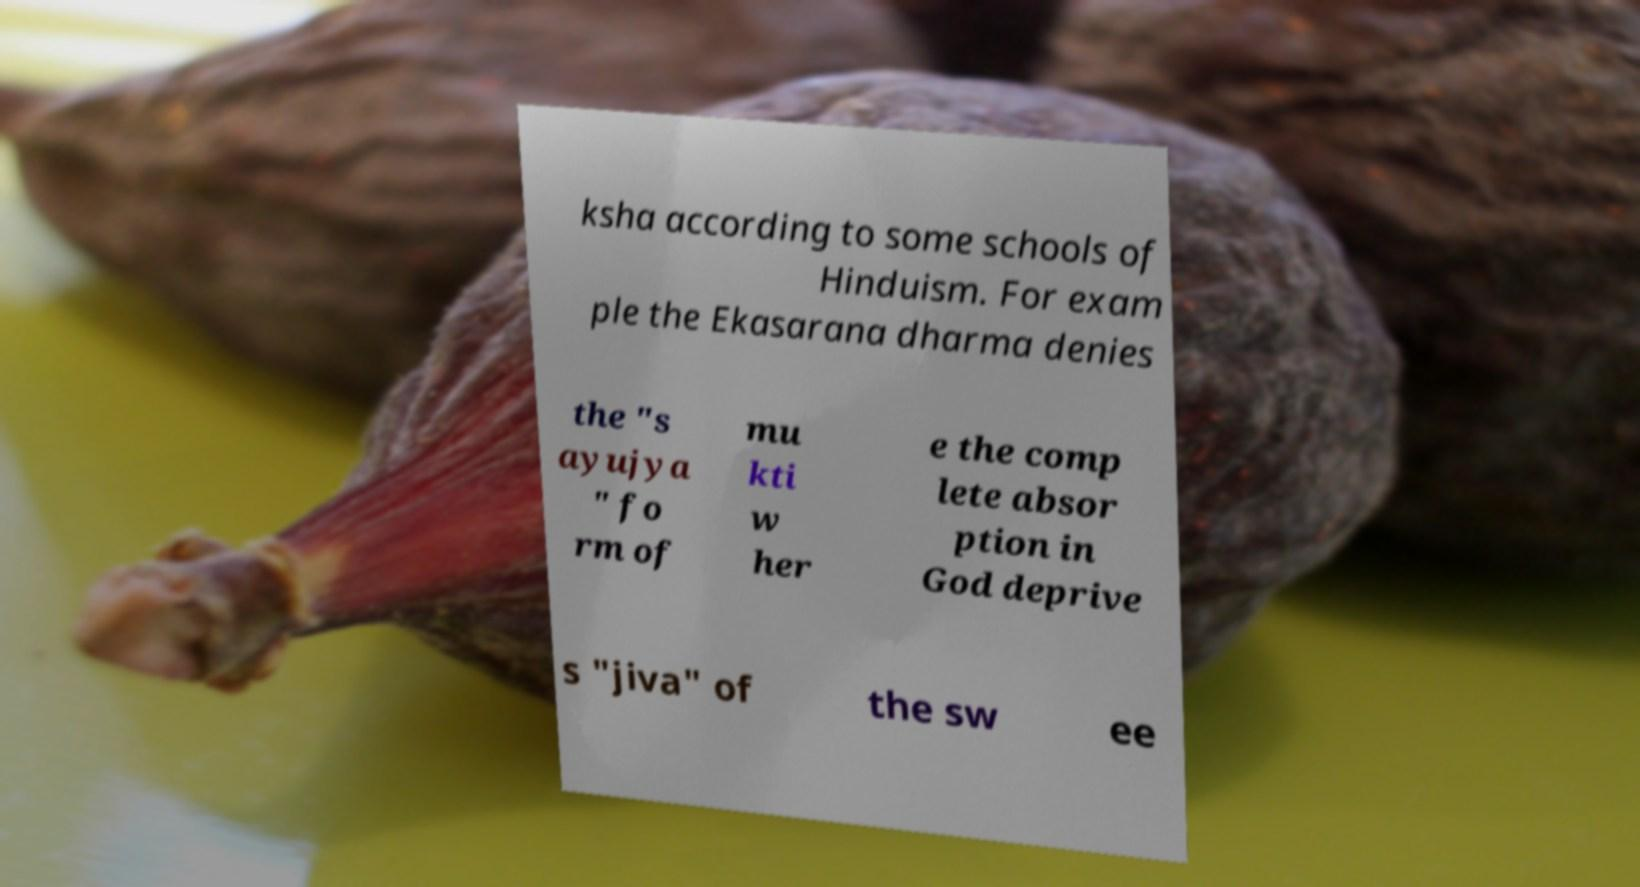What messages or text are displayed in this image? I need them in a readable, typed format. ksha according to some schools of Hinduism. For exam ple the Ekasarana dharma denies the "s ayujya " fo rm of mu kti w her e the comp lete absor ption in God deprive s "jiva" of the sw ee 